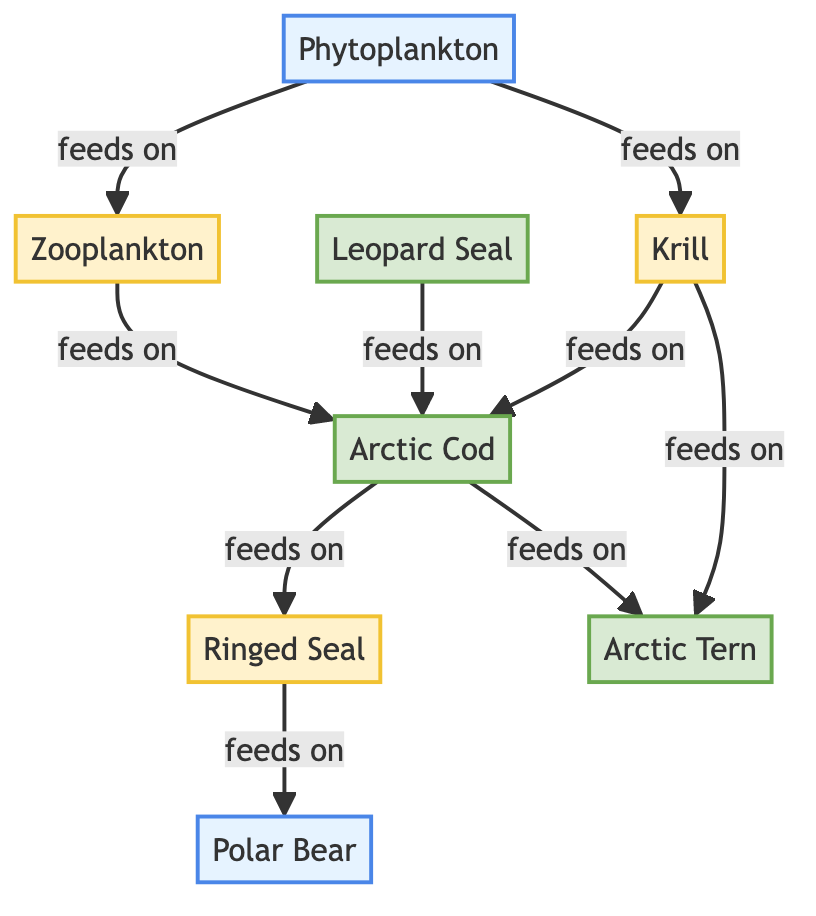What is the primary producer in the Arctic food web? The diagram identifies Phytoplankton as the primary producer, as it is the first node in the food chain. Primary producers are organisms that produce energy through photosynthesis, and in this case, phytoplankton is at the base of the food web.
Answer: Phytoplankton How many secondary consumers are present in the diagram? In the diagram, there are three nodes classified as secondary consumers: Zooplankton, Ringed Seal, and Krill. These consumers feed on primary producers or primary consumers, thus they contribute to the second level in the food web hierarchy.
Answer: 3 Which organism is at the top of the food chain? The diagram shows Polar Bear as the top predator, as it is the final node that consumes other animals in the food chain. This position indicates that it has no natural predators in this specific food web.
Answer: Polar Bear What do Krill and Zooplankton have in common? Both Krill and Zooplankton are classified as secondary consumers in the food web, meaning they feed on primary producers like Phytoplankton. This commonality places them at the same trophic level in this food chain.
Answer: They are secondary consumers Which animal directly feeds on Arctic Cod? According to the diagram, both Ringed Seal and Arctic Tern directly feed on Arctic Cod. This means that Arctic Cod serves as a prey for these two different species in the food web.
Answer: Ringed Seal and Arctic Tern What is the relationship between Phytoplankton and Krill? The relationship shown in the diagram indicates that Phytoplankton serves as a food source for Krill. In ecological terms, this represents a direct trophic interaction whereby Phytoplankton is consumed by Krill, supporting its energy needs.
Answer: Phytoplankton feeds Krill How many organisms are shown as tertiary consumers in the diagram? In the diagram, there are four organisms identified as tertiary consumers: Arctic Cod, Leopard Seal, Arctic Tern, and Ringed Seal. These animals primarily feed on smaller fish or invertebrates, placing them higher in the food chain.
Answer: 4 What feeds on Krill in the Arctic food web? The diagram indicates that Krill is consumed by Arctic Cod and Arctic Tern. This trophic interaction illustrates how Krill is a crucial food source for these species in the Arctic ecosystem.
Answer: Arctic Cod and Arctic Tern Which organism has no natural predators in this food web? The diagram identifies Polar Bear as the only organism with no natural predators within this specific food web, making it the apex predator of the Arctic ecosystem.
Answer: Polar Bear 